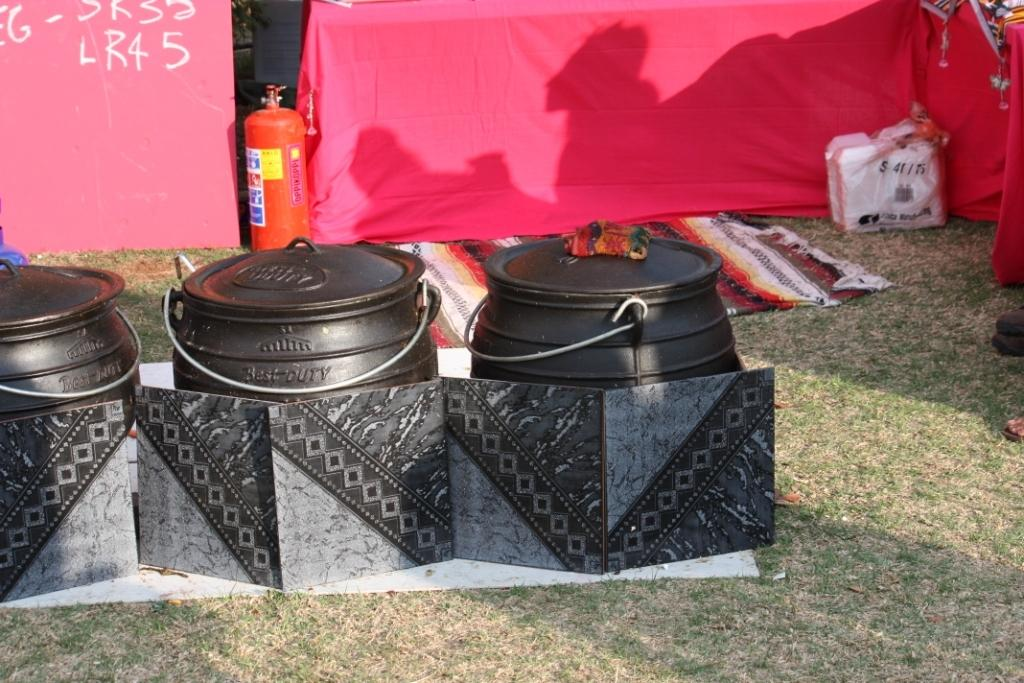What color are the cans in the image? The cans in the image are black. What safety device is present in the image? There is an emergency cylinder in the image. What type of floor covering is visible in the image? There is a floor mat in the image. What can be found on the ground in the image? There are objects on the ground in the image. What color is the cloth visible in the background of the image? There is a red color cloth visible in the background of the image. How many women are depicted working as slaves in the image? There are no women or slaves present in the image. What type of stitch is used to create the red cloth visible in the background of the image? There is no information about the type of stitch used to create the red cloth in the image. 